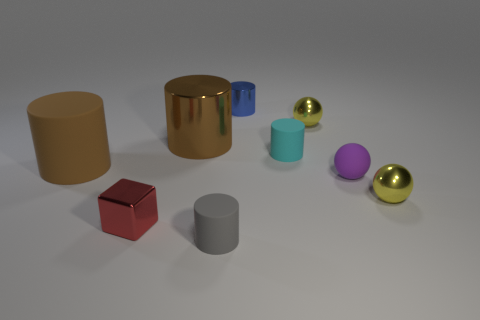What size is the yellow metal thing that is in front of the tiny cylinder right of the small blue metal thing?
Make the answer very short. Small. What is the material of the tiny yellow object to the right of the matte sphere?
Provide a short and direct response. Metal. How many objects are tiny balls that are in front of the big matte thing or small yellow metal things in front of the brown metallic cylinder?
Give a very brief answer. 2. What material is the small blue object that is the same shape as the brown metallic thing?
Your answer should be compact. Metal. There is a big object that is on the left side of the tiny red metallic block; does it have the same color as the metallic cylinder that is in front of the blue cylinder?
Offer a terse response. Yes. Are there any cyan rubber spheres that have the same size as the purple sphere?
Your response must be concise. No. What is the material of the small cylinder that is both behind the tiny purple sphere and in front of the small blue object?
Make the answer very short. Rubber. How many matte objects are either small purple cylinders or large cylinders?
Ensure brevity in your answer.  1. There is a cyan thing that is made of the same material as the small purple object; what shape is it?
Ensure brevity in your answer.  Cylinder. What number of cylinders are both on the left side of the gray rubber cylinder and behind the brown rubber cylinder?
Your answer should be very brief. 1. 